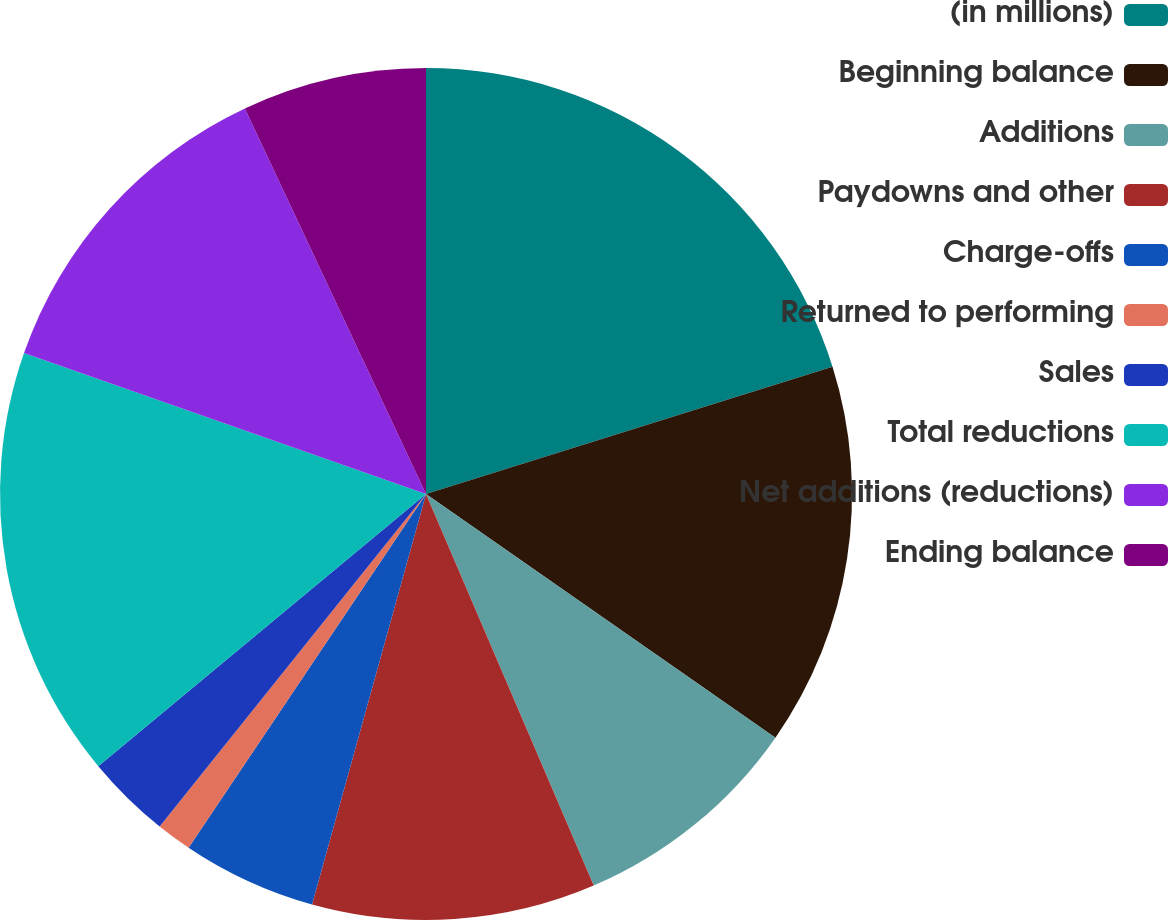Convert chart. <chart><loc_0><loc_0><loc_500><loc_500><pie_chart><fcel>(in millions)<fcel>Beginning balance<fcel>Additions<fcel>Paydowns and other<fcel>Charge-offs<fcel>Returned to performing<fcel>Sales<fcel>Total reductions<fcel>Net additions (reductions)<fcel>Ending balance<nl><fcel>20.17%<fcel>14.52%<fcel>8.87%<fcel>10.75%<fcel>5.1%<fcel>1.34%<fcel>3.22%<fcel>16.4%<fcel>12.64%<fcel>6.99%<nl></chart> 